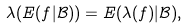Convert formula to latex. <formula><loc_0><loc_0><loc_500><loc_500>\lambda ( E ( f | \mathcal { B } ) ) = E ( \lambda ( f ) | \mathcal { B } ) ,</formula> 